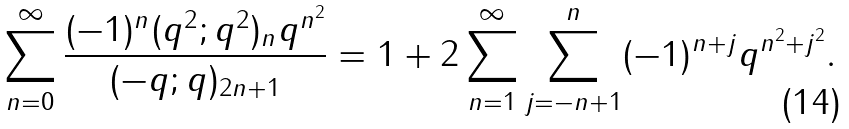<formula> <loc_0><loc_0><loc_500><loc_500>\sum _ { n = 0 } ^ { \infty } \frac { ( - 1 ) ^ { n } ( q ^ { 2 } ; q ^ { 2 } ) _ { n } q ^ { n ^ { 2 } } } { ( - q ; q ) _ { 2 n + 1 } } = 1 + 2 \sum _ { n = 1 } ^ { \infty } \sum _ { j = - n + 1 } ^ { n } ( - 1 ) ^ { n + j } q ^ { n ^ { 2 } + j ^ { 2 } } .</formula> 